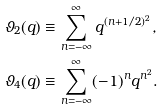Convert formula to latex. <formula><loc_0><loc_0><loc_500><loc_500>\vartheta _ { 2 } ( q ) & \equiv \sum _ { n = - \infty } ^ { \infty } q ^ { ( n + 1 / 2 ) ^ { 2 } } , \\ \vartheta _ { 4 } ( q ) & \equiv \sum _ { n = - \infty } ^ { \infty } ( - 1 ) ^ { n } q ^ { n ^ { 2 } } .</formula> 